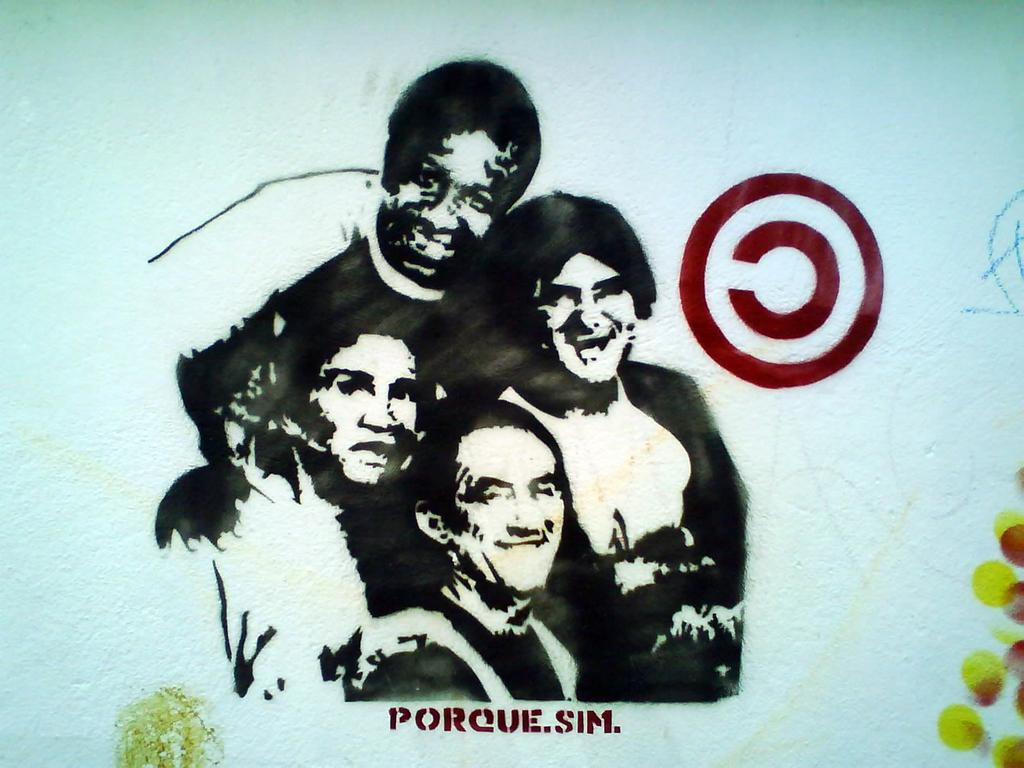What is the main subject of the image? The main subject of the image is a sketch of people. Where is the sketch of people located in the image? The sketch of people is in the center of the image. What else can be seen in the image besides the sketch of people? There is text written in the background of the image. What type of whistle is being used by the people in the image? There is no whistle present in the image; it features a sketch of people and text in the background. 